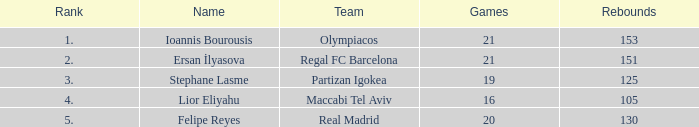What rank is Partizan Igokea that has less than 130 rebounds? 3.0. 